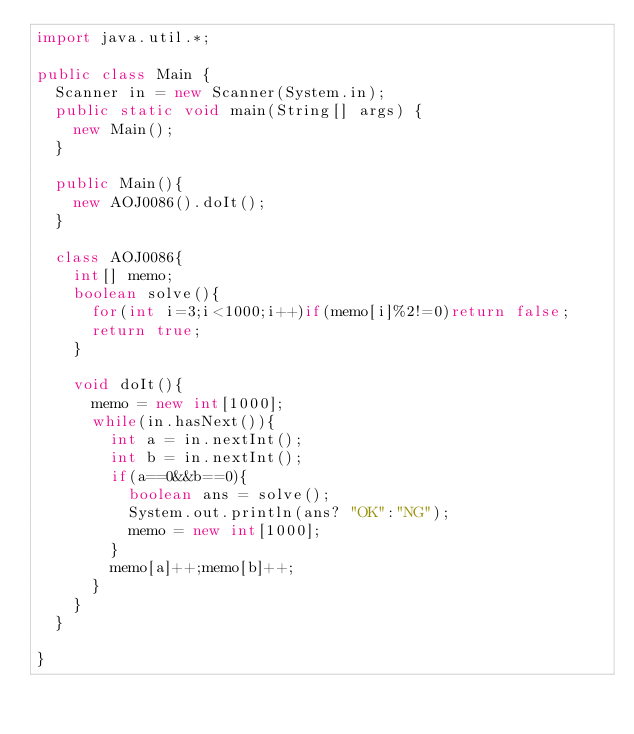Convert code to text. <code><loc_0><loc_0><loc_500><loc_500><_Java_>import java.util.*;

public class Main {
	Scanner in = new Scanner(System.in);
	public static void main(String[] args) {
		new Main();
	}

	public Main(){
		new AOJ0086().doIt();
	}
	
	class AOJ0086{
		int[] memo;
		boolean solve(){
			for(int i=3;i<1000;i++)if(memo[i]%2!=0)return false;
			return true;
		}
		
		void doIt(){
			memo = new int[1000];
			while(in.hasNext()){
				int a = in.nextInt();
				int b = in.nextInt();
				if(a==0&&b==0){
					boolean ans = solve();
					System.out.println(ans? "OK":"NG");
					memo = new int[1000];
				}
				memo[a]++;memo[b]++;
			}
		}
	}
	
}</code> 